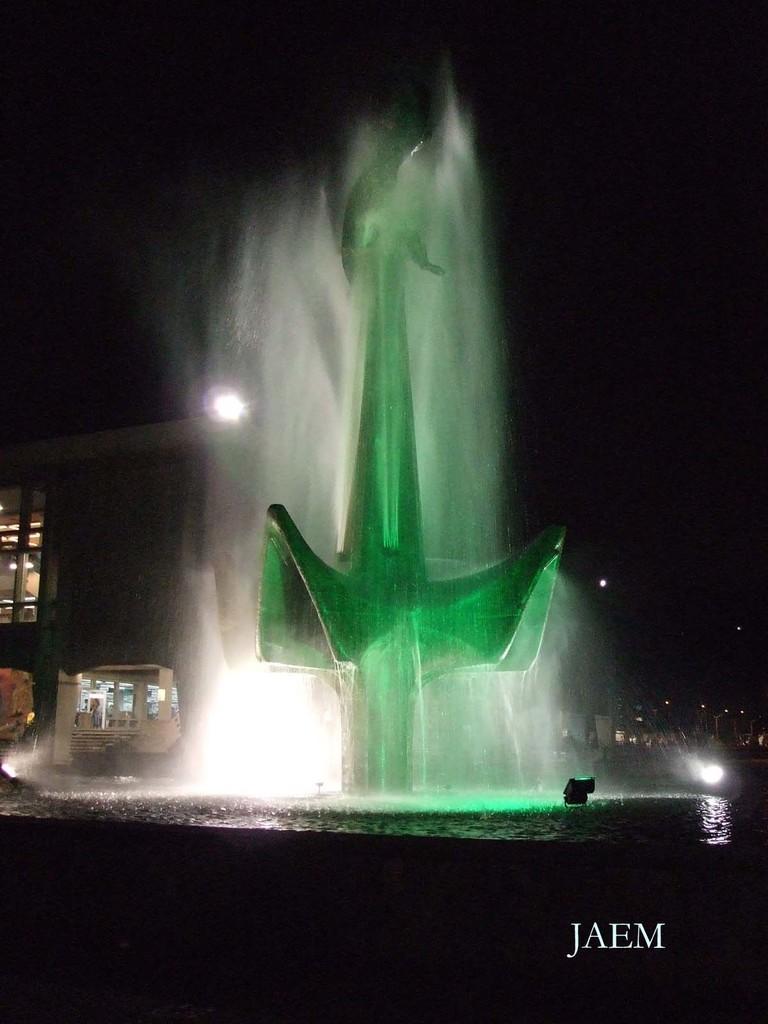Describe this image in one or two sentences. In this picture I can see building and trees in the back and I can see water fountain and looks like a metal architecture in the middle and I can see text at the bottom right corner of the picture and I can see dark background. 